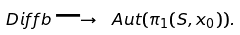Convert formula to latex. <formula><loc_0><loc_0><loc_500><loc_500>\ D i f f b \longrightarrow \ A u t ( \pi _ { 1 } ( S , x _ { 0 } ) ) .</formula> 